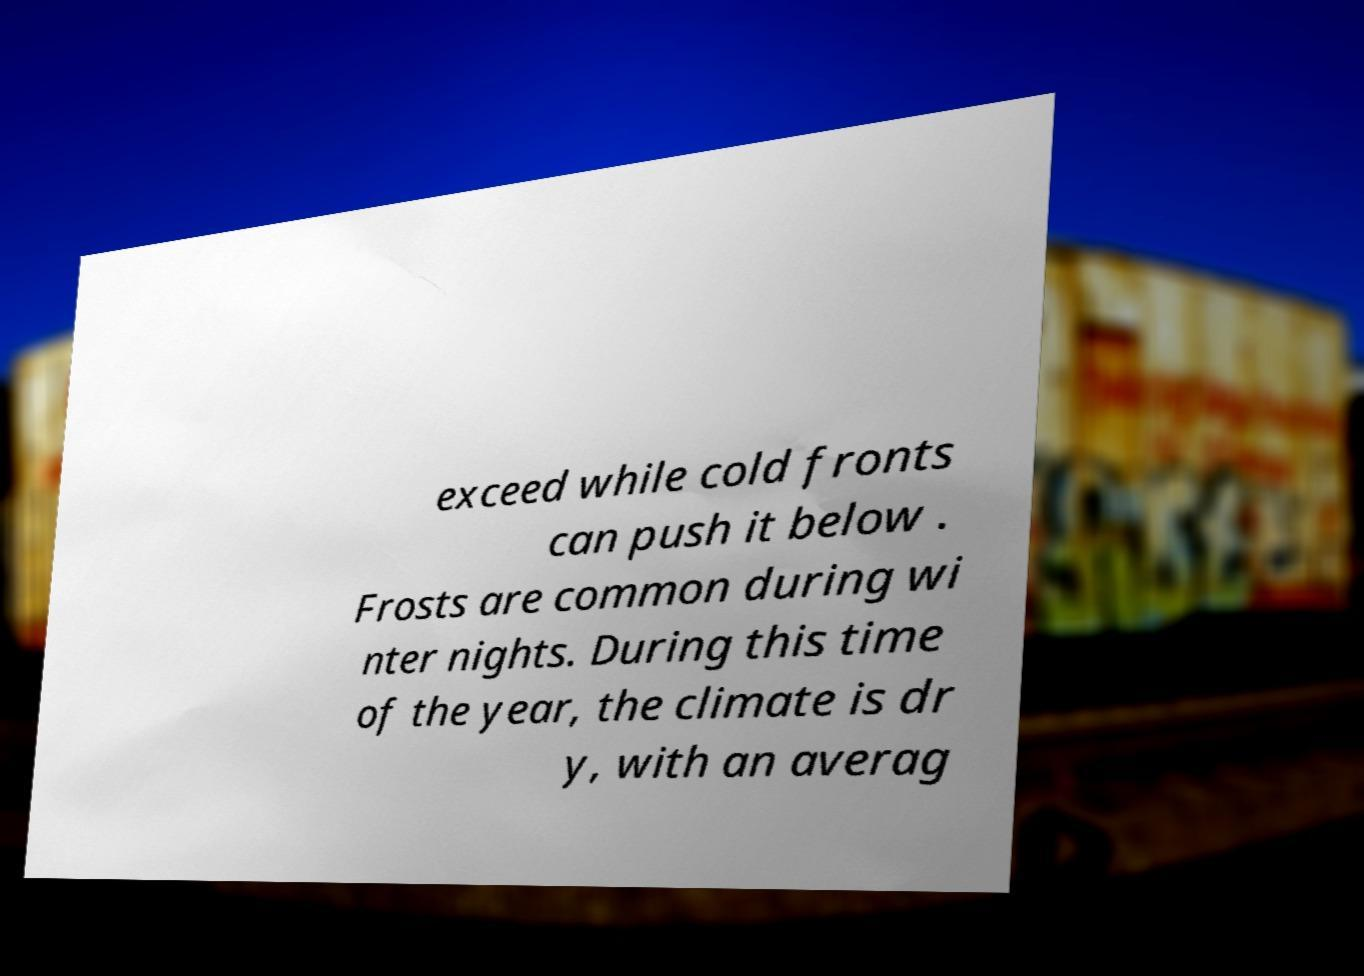What messages or text are displayed in this image? I need them in a readable, typed format. exceed while cold fronts can push it below . Frosts are common during wi nter nights. During this time of the year, the climate is dr y, with an averag 